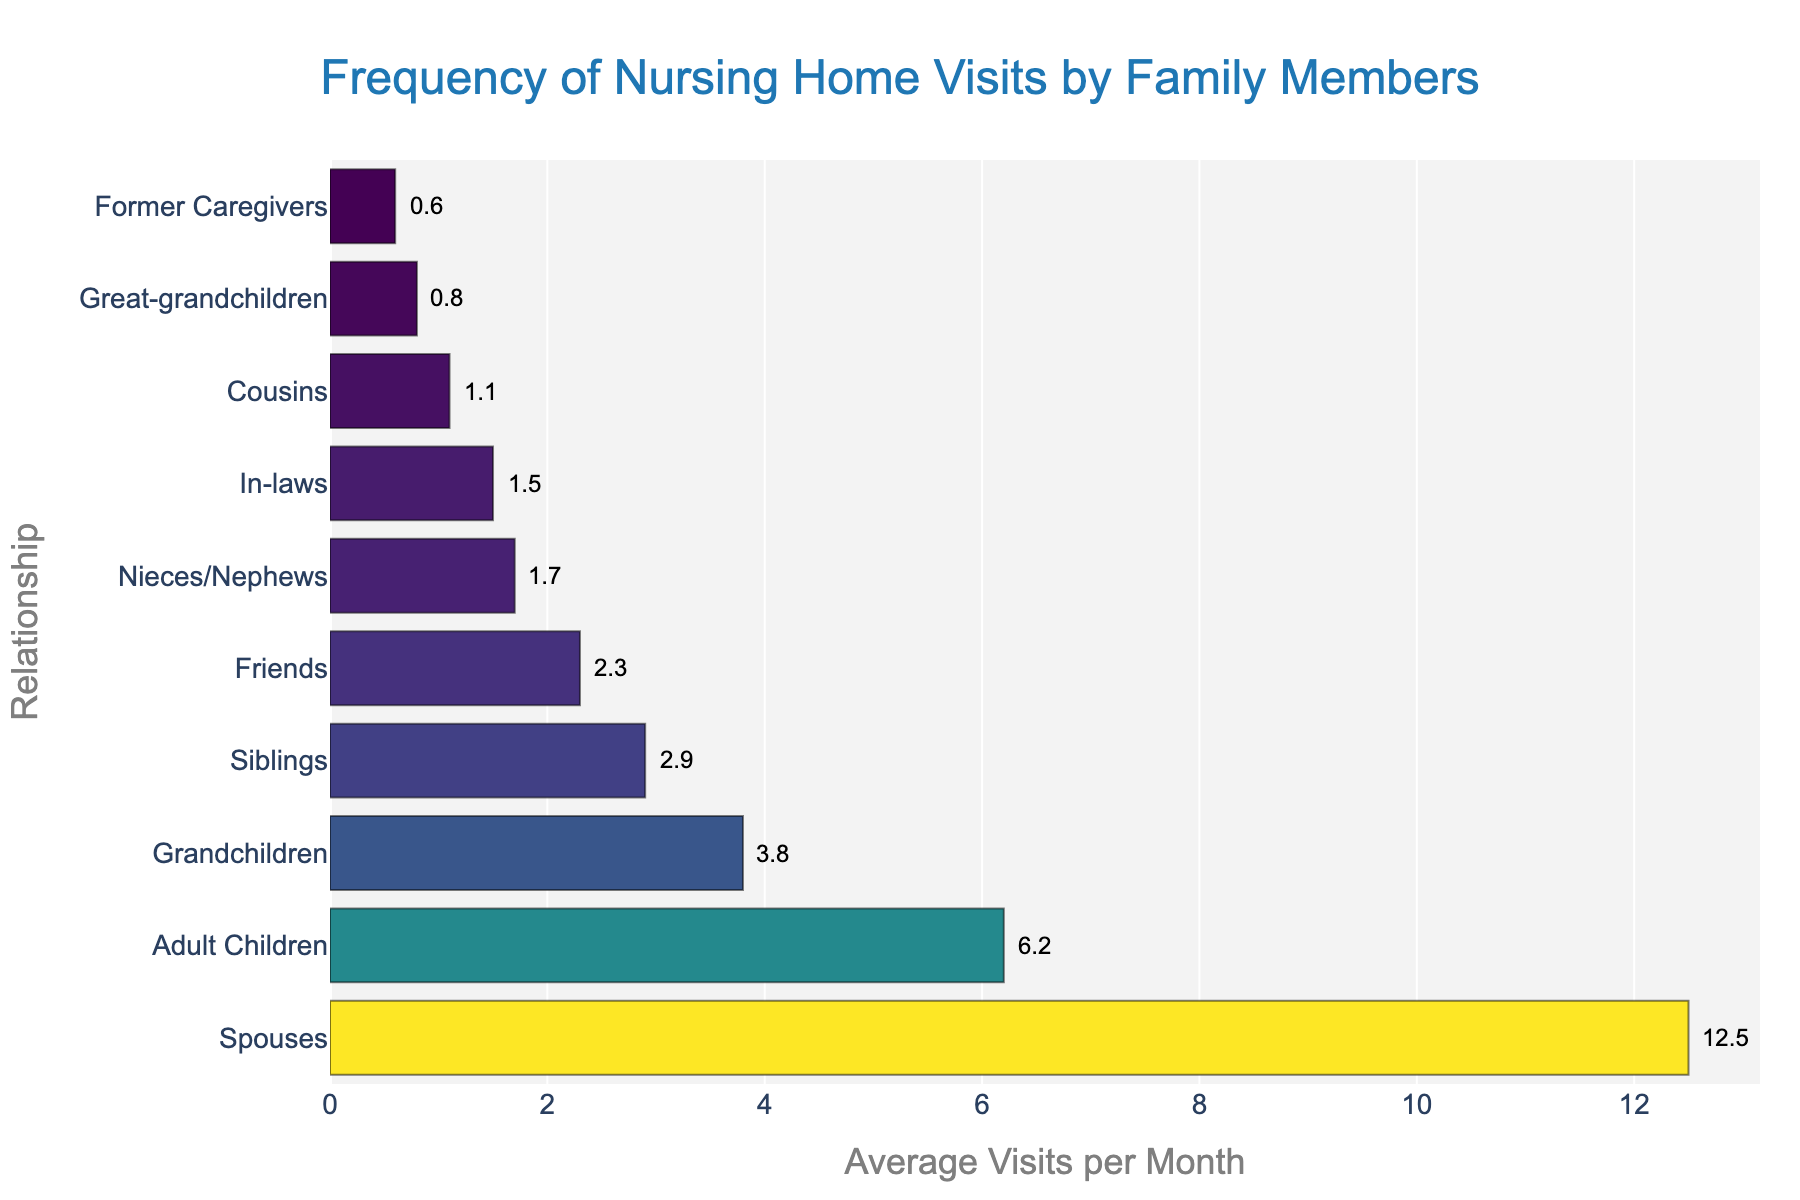Which relationship group visits nursing homes most frequently? The bar representing the "Spouses" category is the longest bar on the plot.
Answer: Spouses How many average visits per month do adult children make compared to spouses? The "Adult Children" bar shows 6.2 visits per month, whereas the "Spouses" bar shows 12.5 visits per month. Subtract 6.2 from 12.5 to find the difference.
Answer: 6.3 Which groups have less than 2 average visits per month? The bars representing "In-laws", "Great-grandchildren", "Former Caregivers", "Cousins", and "Nieces/Nephews" are all less than 2 visits per month.
Answer: In-laws, Great-grandchildren, Former Caregivers, Cousins, Nieces/Nephews What is the combined average number of visits per month by siblings and friends? The bar for "Siblings" is 2.9 and the bar for "Friends" is 2.3. Add these values together: 2.9 + 2.3 = 5.2
Answer: 5.2 Which group has a higher average visit per month: grandchildren or nieces/nephews? The bar for "Grandchildren" shows 3.8 visits per month, while the bar for "Nieces/Nephews" shows 1.7 visits per month.
Answer: Grandchildren What is the average (mean) number of visits per month across all groups? Add up all the average visits (6.2 + 12.5 + 3.8 + 2.9 + 1.7 + 2.3 + 1.1 + 1.5 + 0.8 + 0.6) and then divide by the number of groups (10). The total is 33.4, so the mean is 33.4 / 10 = 3.34
Answer: 3.34 How much more frequently do great-grandchildren visit compared to former caregivers? The bar for "Great-grandchildren" shows 0.8 visits per month, while the bar for "Former Caregivers" shows 0.6 visits per month. Subtract 0.6 from 0.8.
Answer: 0.2 If the visits from siblings doubled, how many visits per month would that group have? The current average visits for "Siblings" is 2.9. Doubling this value is 2.9 * 2.0.
Answer: 5.8 Which group has the shortest bar, indicating the least frequency of visits? The shortest bar corresponds to the "Former Caregivers" group with 0.6 visits per month.
Answer: Former Caregivers Are there more groups with average visits above 3 compared to those below 3? Count the number of bars with average visits above 3 (Spouses, Adult Children, Grandchildren) and those below 3. There are three groups above 3 and seven below 3.
Answer: No 